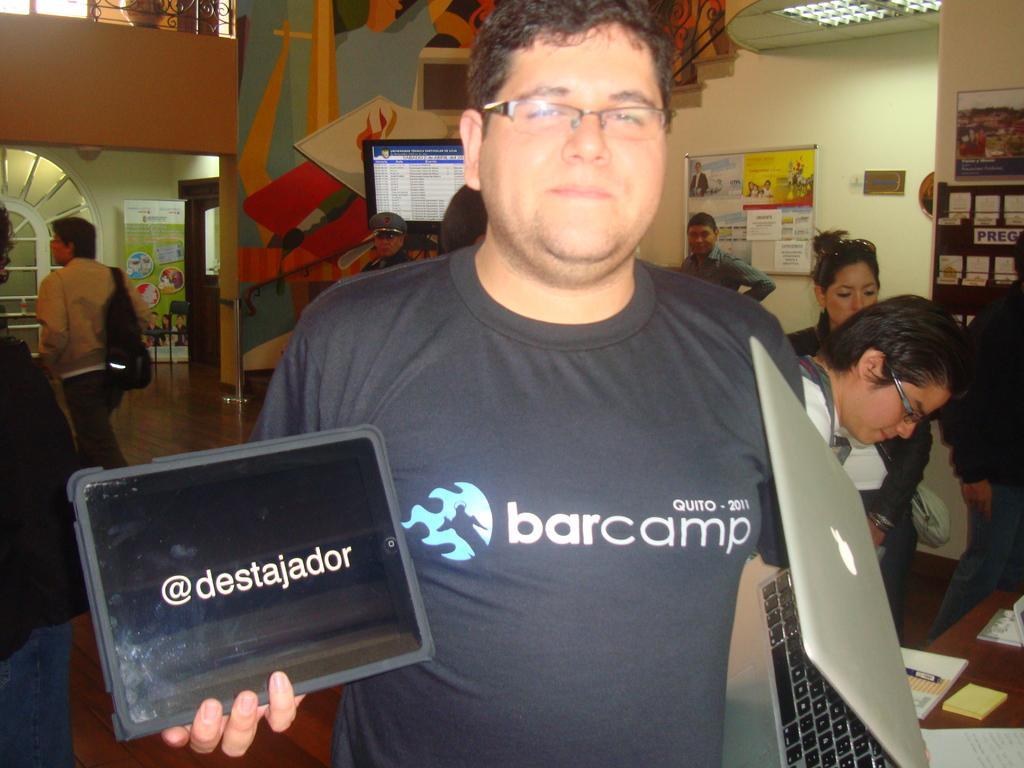Please provide a concise description of this image. Here we can see a man is standing by holding a tab and laptop in his hands. In the background there are few persons and there are posters,a notice board and some other items on the wall,hoarding,screen,fence and pot at the top and on the right at the bottom corner there is a table and on it we can see books and a pen. 